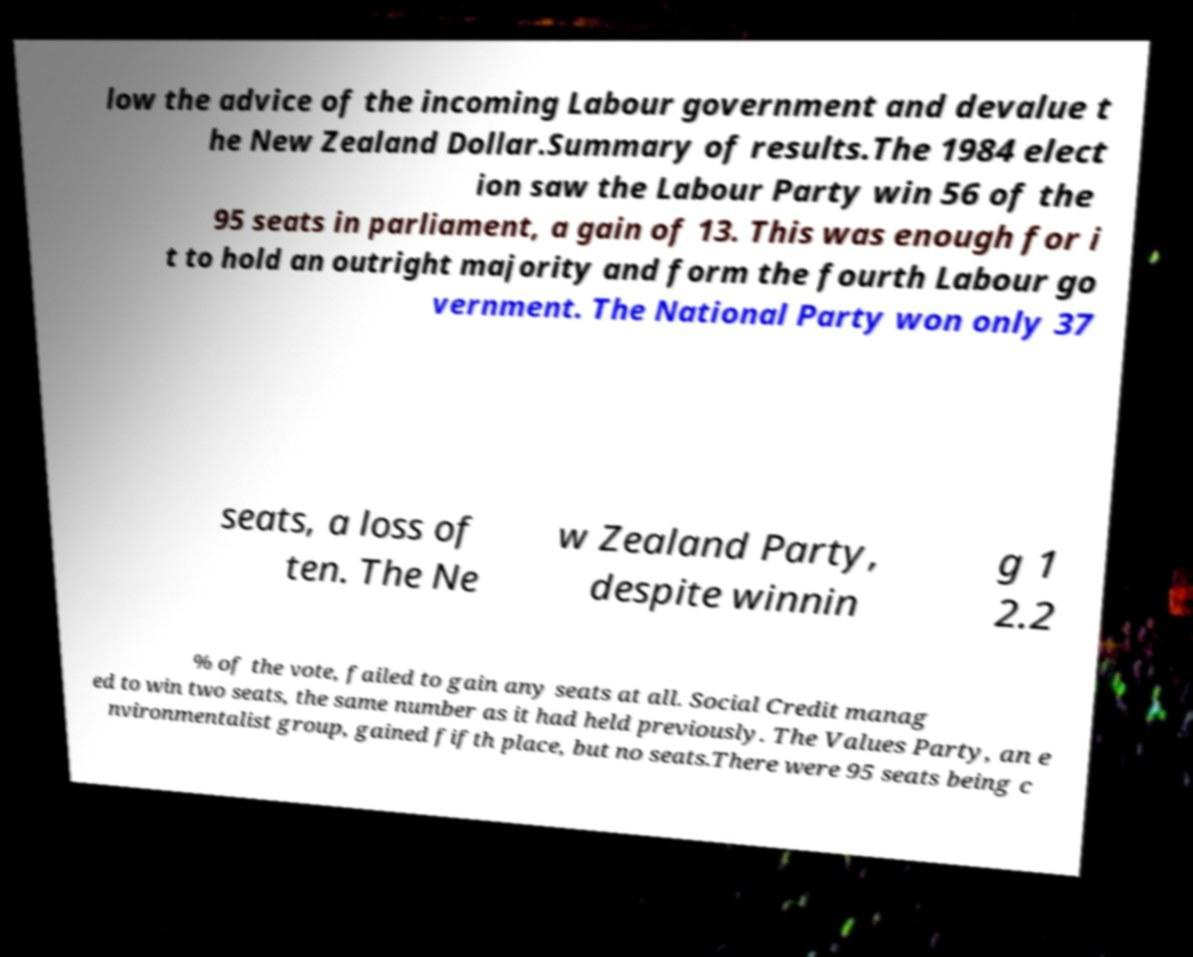Please read and relay the text visible in this image. What does it say? low the advice of the incoming Labour government and devalue t he New Zealand Dollar.Summary of results.The 1984 elect ion saw the Labour Party win 56 of the 95 seats in parliament, a gain of 13. This was enough for i t to hold an outright majority and form the fourth Labour go vernment. The National Party won only 37 seats, a loss of ten. The Ne w Zealand Party, despite winnin g 1 2.2 % of the vote, failed to gain any seats at all. Social Credit manag ed to win two seats, the same number as it had held previously. The Values Party, an e nvironmentalist group, gained fifth place, but no seats.There were 95 seats being c 